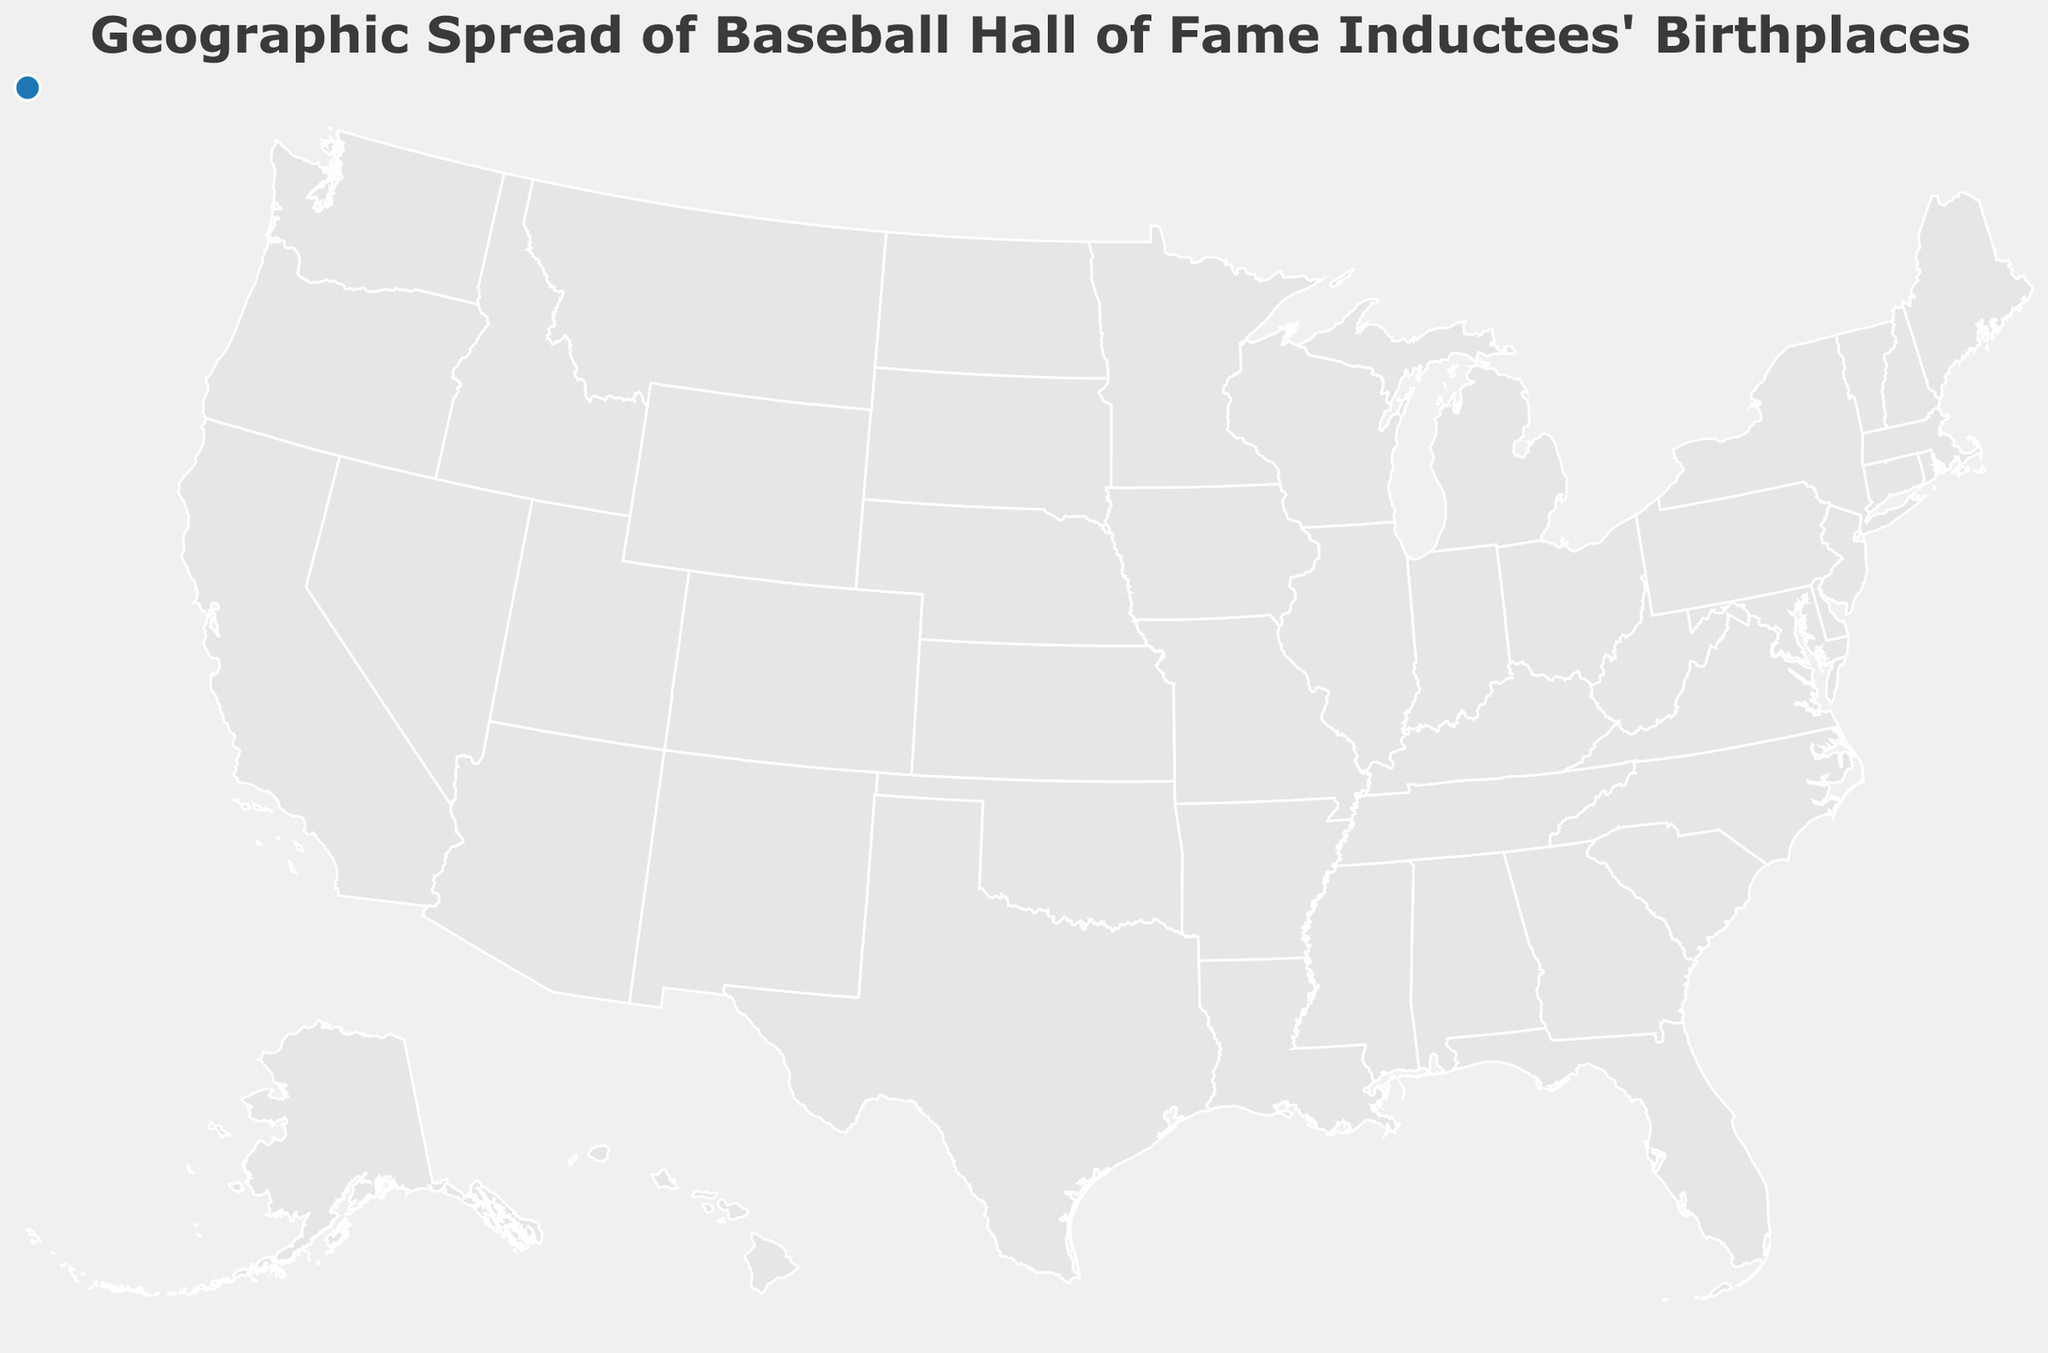Which Hall of Fame inductee's birthplace is marked in the New York area? The tooltip will show the information when you hover over the New York area on the map. Babe Ruth was born in New York.
Answer: Babe Ruth Which states have more than one inductee born there? By examining the tooltip and the plot locations, we see that New York, Massachusetts, and Sudbury (assuming it is an error, Sudbury is not a well-known location for these inductees) have multiple inductees.
Answer: New York, Massachusetts, Sudbury What is the most recent year an inductee was born in the given dataset? By looking at the tooltip's "Year" field, we identify the latest year, which is 2008 for Goose Gossage.
Answer: 2008 Compare the number of Hall of Fame inductees born in New York vs. those born in Massachusetts. Hover over both states to check the number of inductees. New York has 1 (Babe Ruth), and Massachusetts has 1 (Babe Ruth again, counted in two locations).
Answer: Equal (1 each) Which state's inductees have the earliest birth year on this map? Check the tooltip for each state and find the earliest "Year" value. The earliest year is 1936 (multiple locations).
Answer: 1936 What state is Roberto Clemente's birthplace located in? Find Roberto Clemente on the tooltip to determine his birthplace. Roberto Clemente was born in Puerto Rico.
Answer: Puerto Rico How many inductees were born in the state of Texas? Look at Texas on the map and check the tooltip to count the inductees. Texas (Waco) has 1 inductee, Ted Williams.
Answer: 1 Is there any state in the data that only has Hall of Fame inductees born after the year 1970? By checking each tooltip for the inductees' years in each state, we find that Colorado (Goose Gossage), Florida (Wade Boggs), New Jersey (Larry Doby), Arizona (Reggie Jackson), and Colorado (Goose Gossage) meet the criteria.
Answer: Colorado, Florida, New Jersey, Arizona Which baseball Hall of Fame inductee born in Georgia was inducted earliest? The tooltip provides names and years of inductees from Georgia, revealing Ty Cobb in 1936.
Answer: Ty Cobb, 1936 